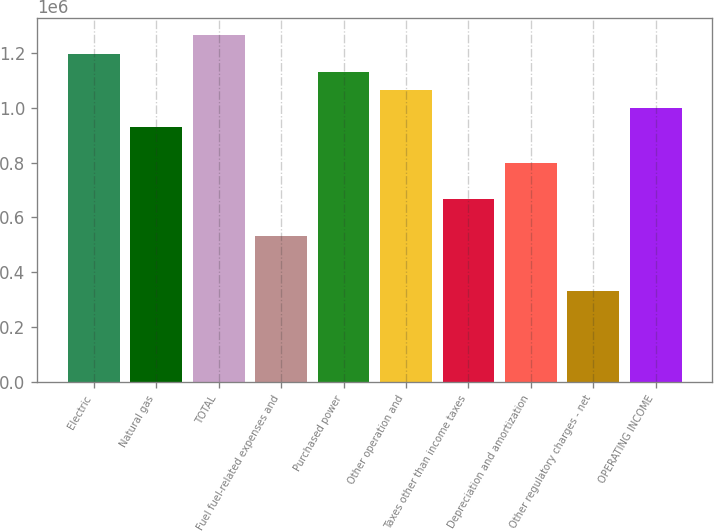<chart> <loc_0><loc_0><loc_500><loc_500><bar_chart><fcel>Electric<fcel>Natural gas<fcel>TOTAL<fcel>Fuel fuel-related expenses and<fcel>Purchased power<fcel>Other operation and<fcel>Taxes other than income taxes<fcel>Depreciation and amortization<fcel>Other regulatory charges - net<fcel>OPERATING INCOME<nl><fcel>1.19763e+06<fcel>931546<fcel>1.26415e+06<fcel>532422<fcel>1.13111e+06<fcel>1.06459e+06<fcel>665463<fcel>798504<fcel>332860<fcel>998066<nl></chart> 